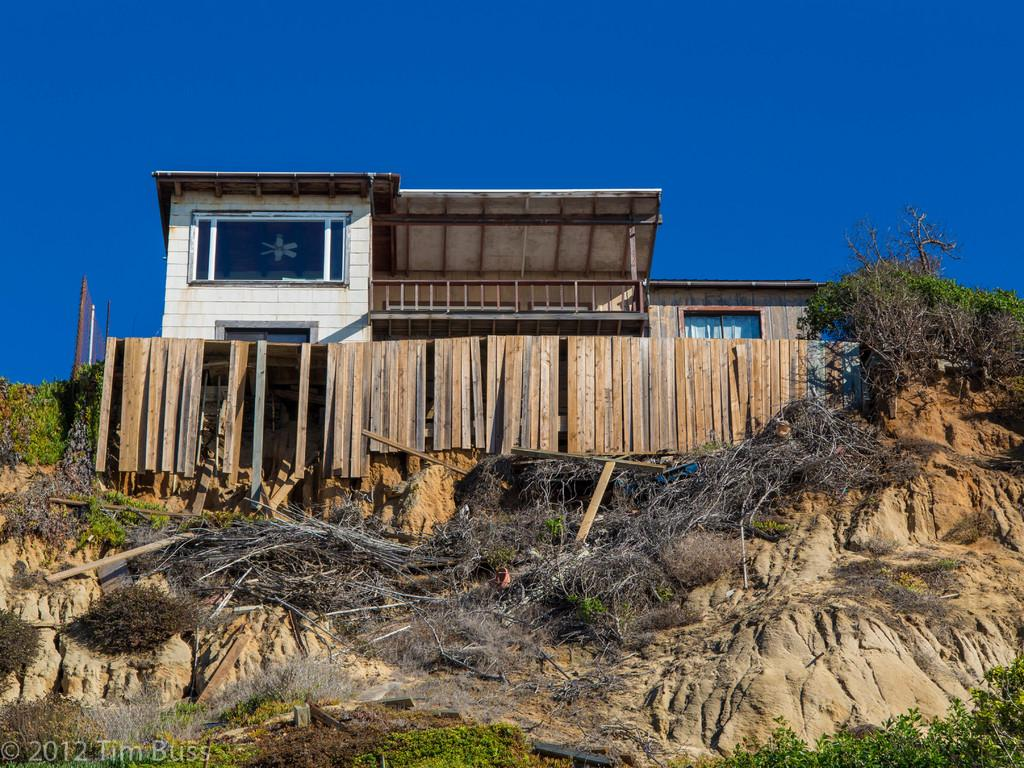What is the main subject in the middle of the image? There is a house in the middle of the image. What can be found at the bottom of the image? At the bottom of the image, there are plants, stones, wooden sticks, a fence, trees, and text. What is visible at the top of the image? At the top of the image, there is sky. What news is being reported by the oranges in the image? There are no oranges present in the image, and therefore no news can be reported by them. 